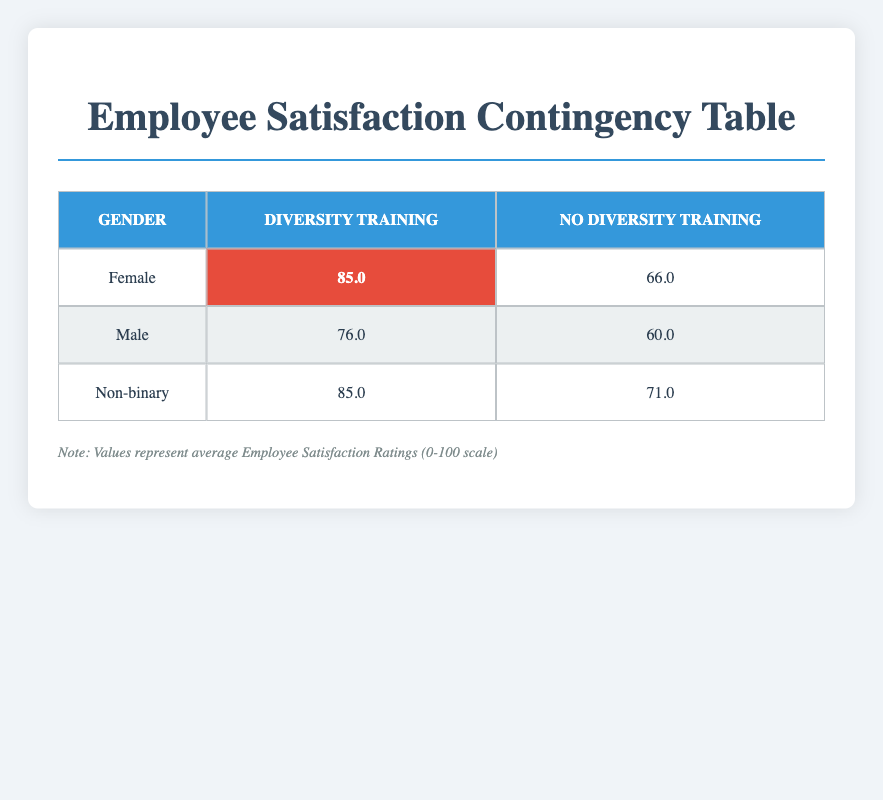What is the average employee satisfaction rating for female employees who participated in diversity training? From the table, the average satisfaction rating for female employees who participated in diversity training is 85.0.
Answer: 85.0 What is the employee satisfaction rating for male employees who did not participate in diversity training? Referring to the table, the rating for male employees who did not participate in diversity training is 60.0.
Answer: 60.0 Is the average employee satisfaction rating higher for employees who attended diversity training compared to those who did not? To answer this, we compare the averages: Female with training: 85.0; Male with training: 76.0; Non-binary with training: 85.0. For those without training: Female: 66.0; Male: 60.0; Non-binary: 71.0. The overall average for training attendees (82.0) is higher than those who did not attend (65.7).
Answer: Yes What is the difference in employee satisfaction ratings between male employees who attended and those who did not attend diversity training? The rating for males who participated in diversity training is 76.0, whereas it is 60.0 for those who did not. The difference is 76.0 - 60.0 = 16.0.
Answer: 16.0 Among all groups, which gender has the highest average employee satisfaction rating after attending diversity training? The ratings for diversity-trained individuals are as follows: Female: 85.0, Male: 76.0, Non-binary: 85.0. Both Female and Non-binary have the highest average of 85.0.
Answer: Female and Non-binary What is the lowest average employee satisfaction rating reported in the table? The lowest rating among all groups is for male employees who did not attend diversity training, which is 60.0.
Answer: 60.0 Is the employee satisfaction rating for non-binary employees higher than that of female employees who did not attend diversity training? The rating for non-binary employees who did not attend is 71.0, while for females who did not attend, it is 66.0. Since 71.0 > 66.0, the statement is true.
Answer: Yes What is the combined average employee satisfaction rating for all employees who participated in diversity training? For those who attended, the ratings are: Female (85.0 average, two data points), Male (76.0 average, two data points), Non-binary (85.0 average, one data point). The total is (85.0 + 88.0 + 76.0 + 77.0 + 85.0) / 5 = 82.0.
Answer: 82.0 How many different gender categories are represented in the table? The table categorizes employees by three genders: Female, Male, and Non-binary, thus there are three different categories present.
Answer: Three 